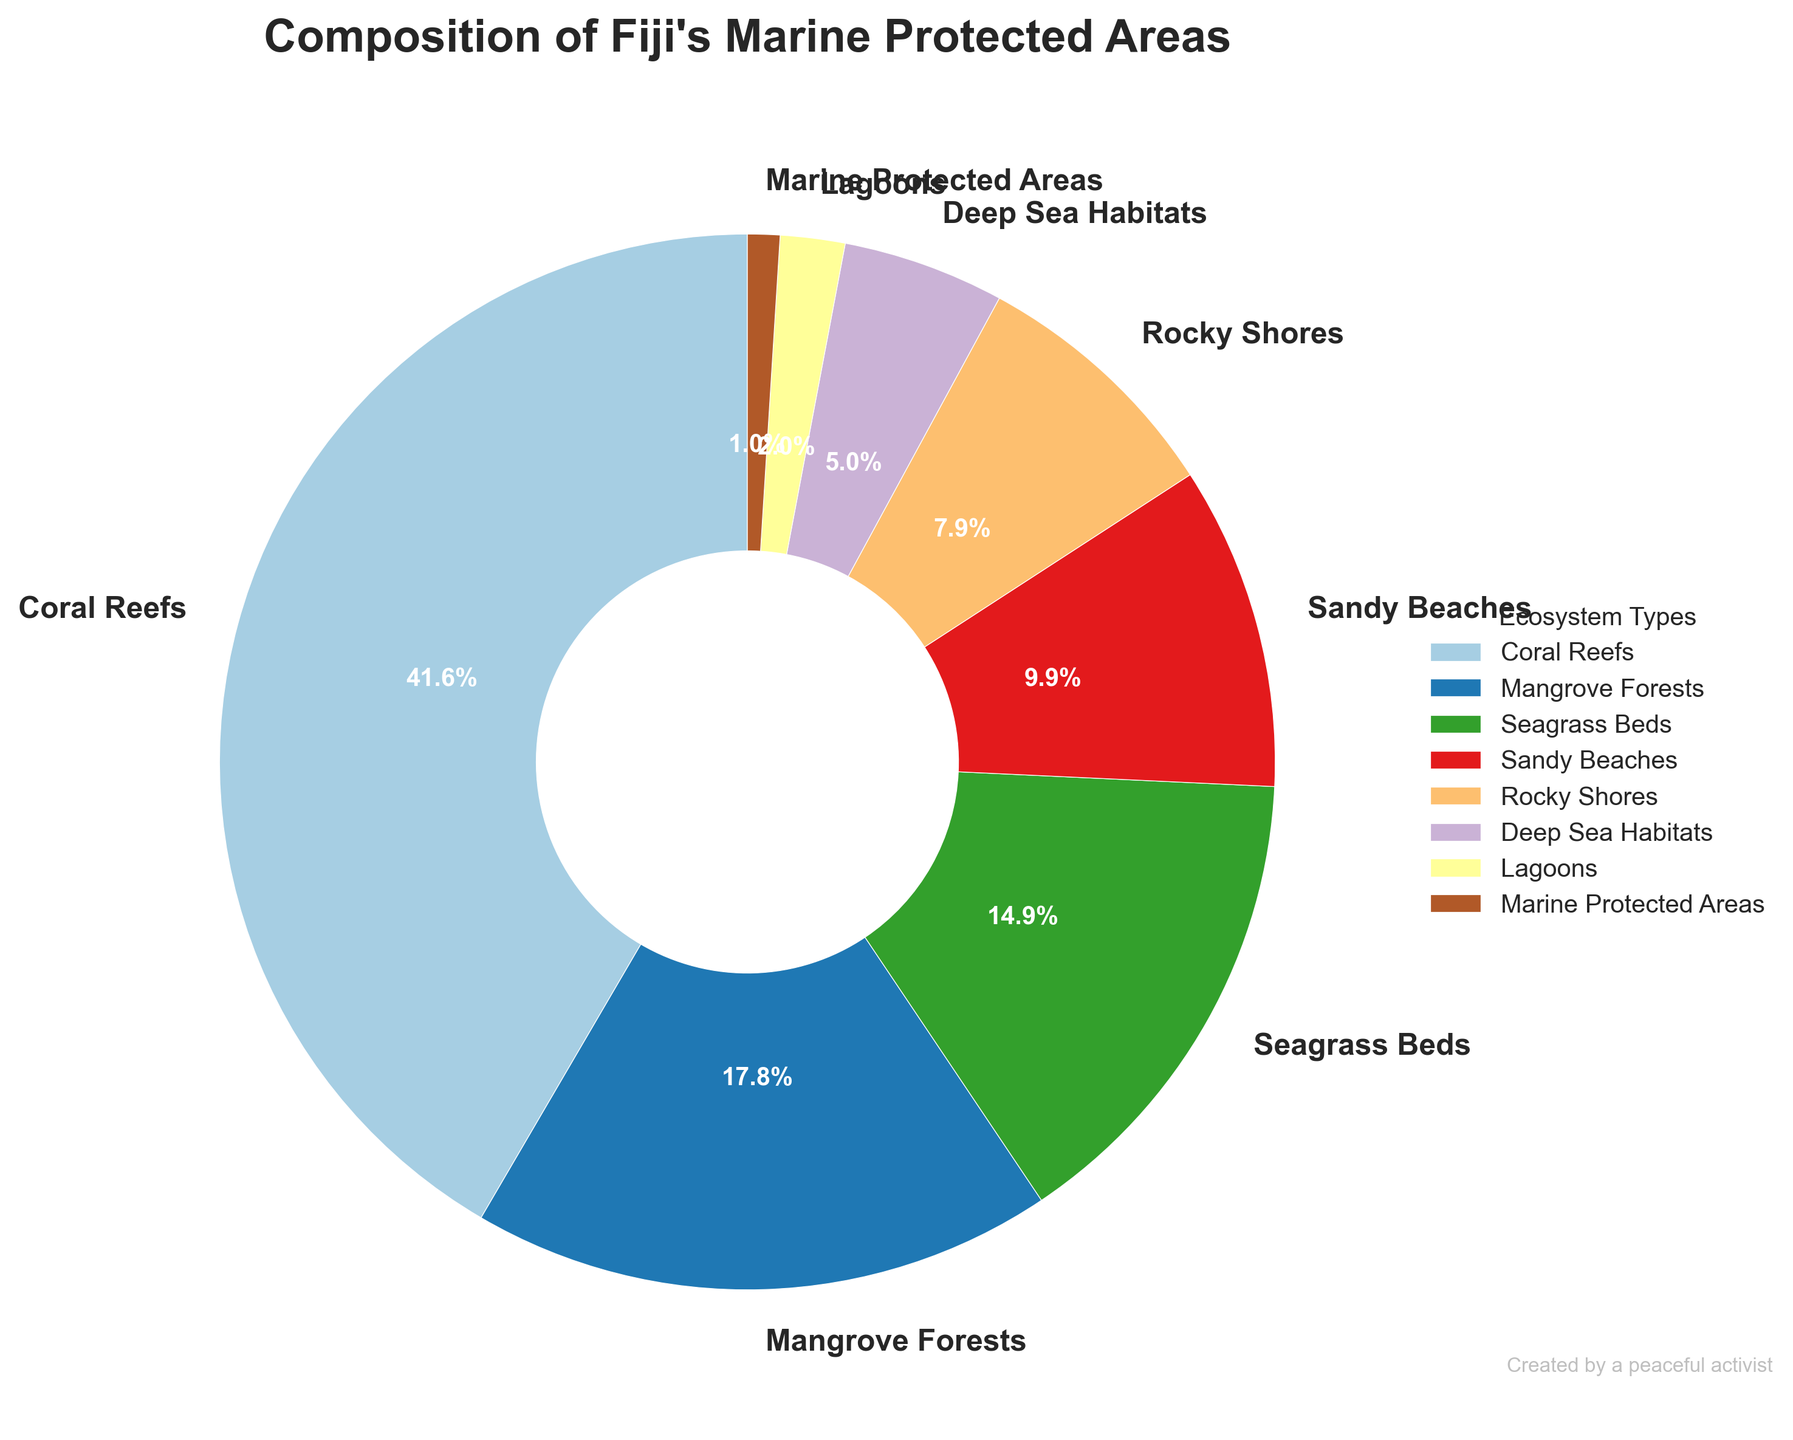What percentage of Fiji's marine protected areas is composed of Coral Reefs and Mangrove Forests together? To find the combined percentage of Coral Reefs and Mangrove Forests, add the individual percentages: 42% (Coral Reefs) + 18% (Mangrove Forests) = 60%.
Answer: 60% Which ecosystem type comprises the smallest percentage of Fiji's marine protected areas? By examining the slices in the pie chart, the smallest slice corresponds to Marine Protected Areas at 1%.
Answer: Marine Protected Areas Is the percentage composition of Seagrass Beds higher than the combined percentage of Sandy Beaches and Rocky Shores? Compare 15% (Seagrass Beds) with the sum of Sandy Beaches (10%) and Rocky Shores (8%), which is 10% + 8% = 18%. Since 15% is less than 18%, the answer is no.
Answer: No What is the combined percentage of the ecosystem types that individually make up less than 10% of Fiji's marine protected areas? Add the percentages of the types below 10%: Sandy Beaches (10%), Rocky Shores (8%), Deep Sea Habitats (5%), Lagoons (2%), Marine Protected Areas (1%). Their sum is 10% + 8% + 5% + 2% + 1% = 26%.
Answer: 26% Which ecosystem type is depicted with the largest slice, and what color is it represented with? The largest slice is for Coral Reefs, which makes up 42%. In the pie chart, this is represented with a color close to the first in the Paired colormap, typically a shade from the beginning of the spectrum.
Answer: Coral Reefs, color varies depending on the colormap settings but often a bright shade Is the combined percentage of Coral Reefs and Seagrass Beds less than the combined percentage of Mangrove Forests and Sandy Beaches? Compare the sum of Coral Reefs (42%) + Seagrass Beds (15%) = 57% with Mangrove Forests (18%) + Sandy Beaches (10%) = 28%, so 57% > 28%.
Answer: No What is the difference in percentage between Deep Sea Habitats and Lagoons? Subtract the percentage of Lagoons from Deep Sea Habitats: 5% (Deep Sea Habitats) - 2% (Lagoons) = 3%.
Answer: 3% If all types adding up to less than 20% were combined into a single category, would it make up a larger percentage than Seagrass Beds? Sum the percentages of Rocky Shores (8%), Deep Sea Habitats (5%), Lagoons (2%), and Marine Protected Areas (1%), which equal 8% + 5% + 2% + 1% = 16%. Compare this with Seagrass Beds at 15%, and 16% is greater than 15%.
Answer: Yes 